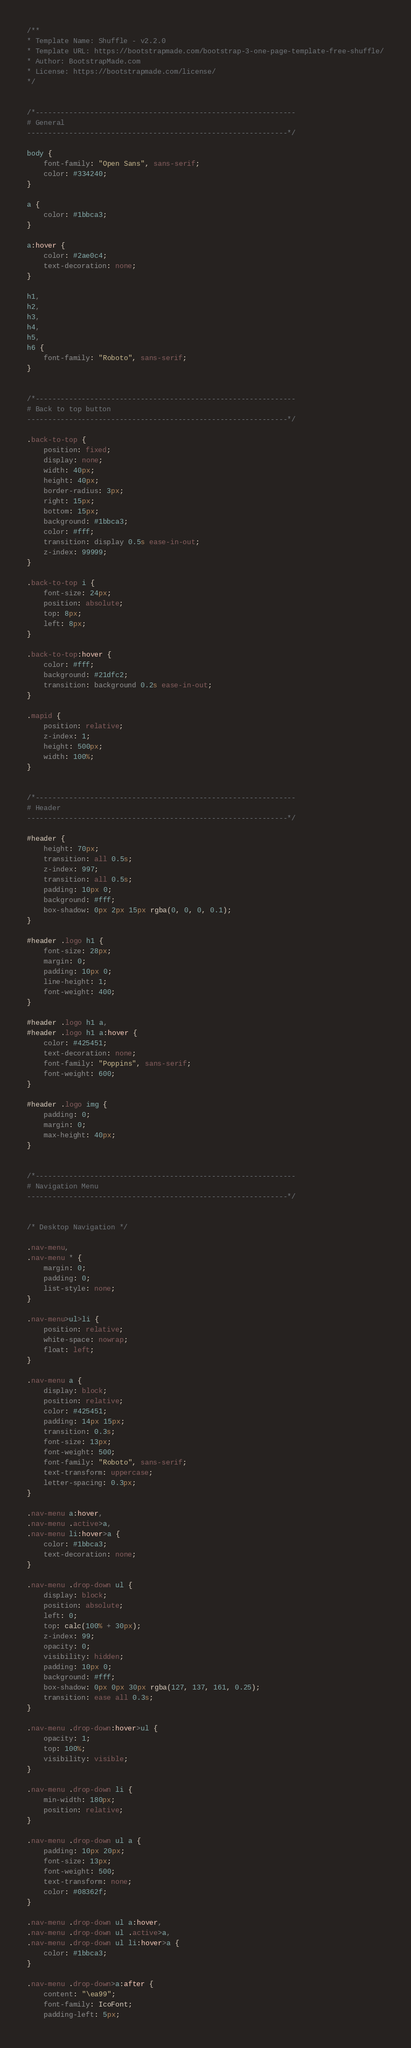<code> <loc_0><loc_0><loc_500><loc_500><_CSS_>/**
* Template Name: Shuffle - v2.2.0
* Template URL: https://bootstrapmade.com/bootstrap-3-one-page-template-free-shuffle/
* Author: BootstrapMade.com
* License: https://bootstrapmade.com/license/
*/


/*--------------------------------------------------------------
# General
--------------------------------------------------------------*/

body {
    font-family: "Open Sans", sans-serif;
    color: #334240;
}

a {
    color: #1bbca3;
}

a:hover {
    color: #2ae0c4;
    text-decoration: none;
}

h1,
h2,
h3,
h4,
h5,
h6 {
    font-family: "Roboto", sans-serif;
}


/*--------------------------------------------------------------
# Back to top button
--------------------------------------------------------------*/

.back-to-top {
    position: fixed;
    display: none;
    width: 40px;
    height: 40px;
    border-radius: 3px;
    right: 15px;
    bottom: 15px;
    background: #1bbca3;
    color: #fff;
    transition: display 0.5s ease-in-out;
    z-index: 99999;
}

.back-to-top i {
    font-size: 24px;
    position: absolute;
    top: 8px;
    left: 8px;
}

.back-to-top:hover {
    color: #fff;
    background: #21dfc2;
    transition: background 0.2s ease-in-out;
}

.mapid {
    position: relative;
    z-index: 1;
    height: 500px;
    width: 100%;
}


/*--------------------------------------------------------------
# Header
--------------------------------------------------------------*/

#header {
    height: 70px;
    transition: all 0.5s;
    z-index: 997;
    transition: all 0.5s;
    padding: 10px 0;
    background: #fff;
    box-shadow: 0px 2px 15px rgba(0, 0, 0, 0.1);
}

#header .logo h1 {
    font-size: 28px;
    margin: 0;
    padding: 10px 0;
    line-height: 1;
    font-weight: 400;
}

#header .logo h1 a,
#header .logo h1 a:hover {
    color: #425451;
    text-decoration: none;
    font-family: "Poppins", sans-serif;
    font-weight: 600;
}

#header .logo img {
    padding: 0;
    margin: 0;
    max-height: 40px;
}


/*--------------------------------------------------------------
# Navigation Menu
--------------------------------------------------------------*/


/* Desktop Navigation */

.nav-menu,
.nav-menu * {
    margin: 0;
    padding: 0;
    list-style: none;
}

.nav-menu>ul>li {
    position: relative;
    white-space: nowrap;
    float: left;
}

.nav-menu a {
    display: block;
    position: relative;
    color: #425451;
    padding: 14px 15px;
    transition: 0.3s;
    font-size: 13px;
    font-weight: 500;
    font-family: "Roboto", sans-serif;
    text-transform: uppercase;
    letter-spacing: 0.3px;
}

.nav-menu a:hover,
.nav-menu .active>a,
.nav-menu li:hover>a {
    color: #1bbca3;
    text-decoration: none;
}

.nav-menu .drop-down ul {
    display: block;
    position: absolute;
    left: 0;
    top: calc(100% + 30px);
    z-index: 99;
    opacity: 0;
    visibility: hidden;
    padding: 10px 0;
    background: #fff;
    box-shadow: 0px 0px 30px rgba(127, 137, 161, 0.25);
    transition: ease all 0.3s;
}

.nav-menu .drop-down:hover>ul {
    opacity: 1;
    top: 100%;
    visibility: visible;
}

.nav-menu .drop-down li {
    min-width: 180px;
    position: relative;
}

.nav-menu .drop-down ul a {
    padding: 10px 20px;
    font-size: 13px;
    font-weight: 500;
    text-transform: none;
    color: #08362f;
}

.nav-menu .drop-down ul a:hover,
.nav-menu .drop-down ul .active>a,
.nav-menu .drop-down ul li:hover>a {
    color: #1bbca3;
}

.nav-menu .drop-down>a:after {
    content: "\ea99";
    font-family: IcoFont;
    padding-left: 5px;</code> 